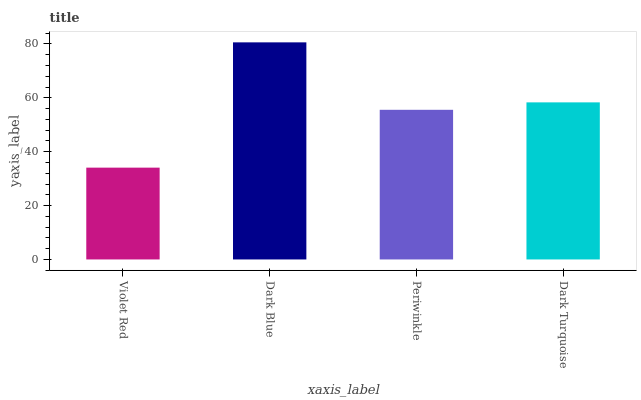Is Violet Red the minimum?
Answer yes or no. Yes. Is Dark Blue the maximum?
Answer yes or no. Yes. Is Periwinkle the minimum?
Answer yes or no. No. Is Periwinkle the maximum?
Answer yes or no. No. Is Dark Blue greater than Periwinkle?
Answer yes or no. Yes. Is Periwinkle less than Dark Blue?
Answer yes or no. Yes. Is Periwinkle greater than Dark Blue?
Answer yes or no. No. Is Dark Blue less than Periwinkle?
Answer yes or no. No. Is Dark Turquoise the high median?
Answer yes or no. Yes. Is Periwinkle the low median?
Answer yes or no. Yes. Is Violet Red the high median?
Answer yes or no. No. Is Violet Red the low median?
Answer yes or no. No. 